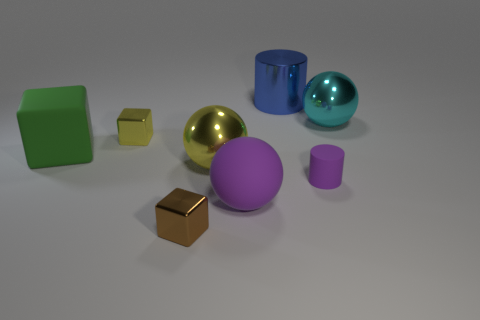What is the size of the brown block that is in front of the tiny metallic thing behind the purple matte object behind the purple matte sphere?
Your answer should be compact. Small. How many yellow objects are made of the same material as the yellow cube?
Provide a succinct answer. 1. Are there fewer large red metal spheres than yellow metal blocks?
Keep it short and to the point. Yes. What is the size of the other thing that is the same shape as the big blue thing?
Offer a terse response. Small. Is the material of the cylinder that is behind the cyan sphere the same as the tiny purple cylinder?
Give a very brief answer. No. Is the shape of the big purple rubber object the same as the big blue shiny object?
Your answer should be very brief. No. What number of objects are large metal things to the left of the large blue cylinder or big blue rubber objects?
Give a very brief answer. 1. What is the size of the yellow cube that is made of the same material as the large cyan thing?
Make the answer very short. Small. How many other large shiny cylinders are the same color as the large cylinder?
Your response must be concise. 0. How many tiny things are either green cubes or green shiny cubes?
Ensure brevity in your answer.  0. 